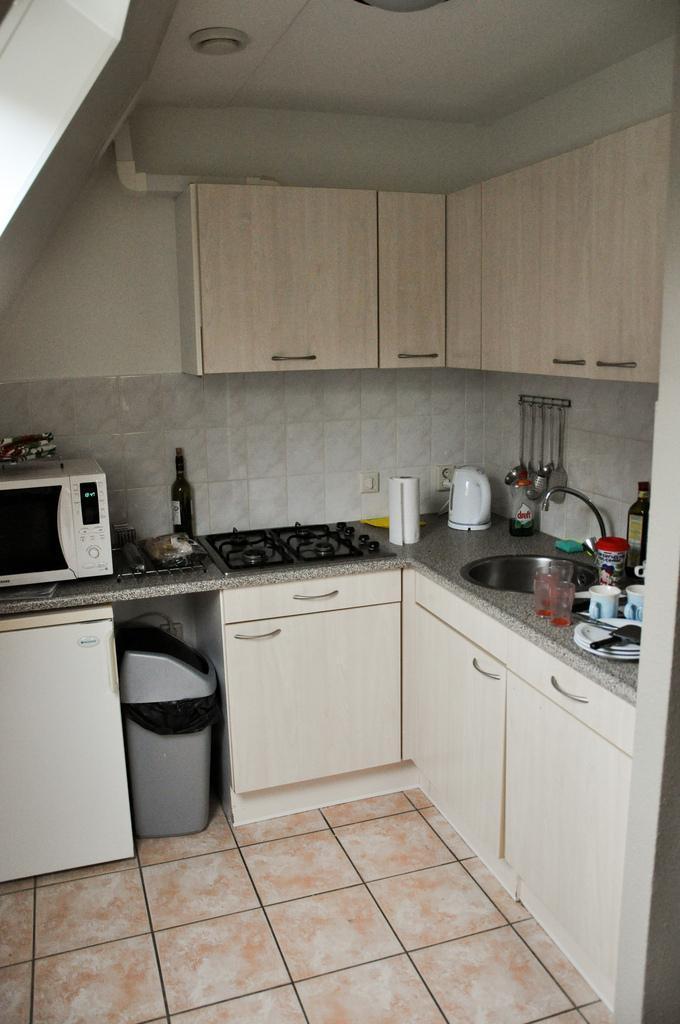How many burners does the stove have?
Give a very brief answer. 4. 